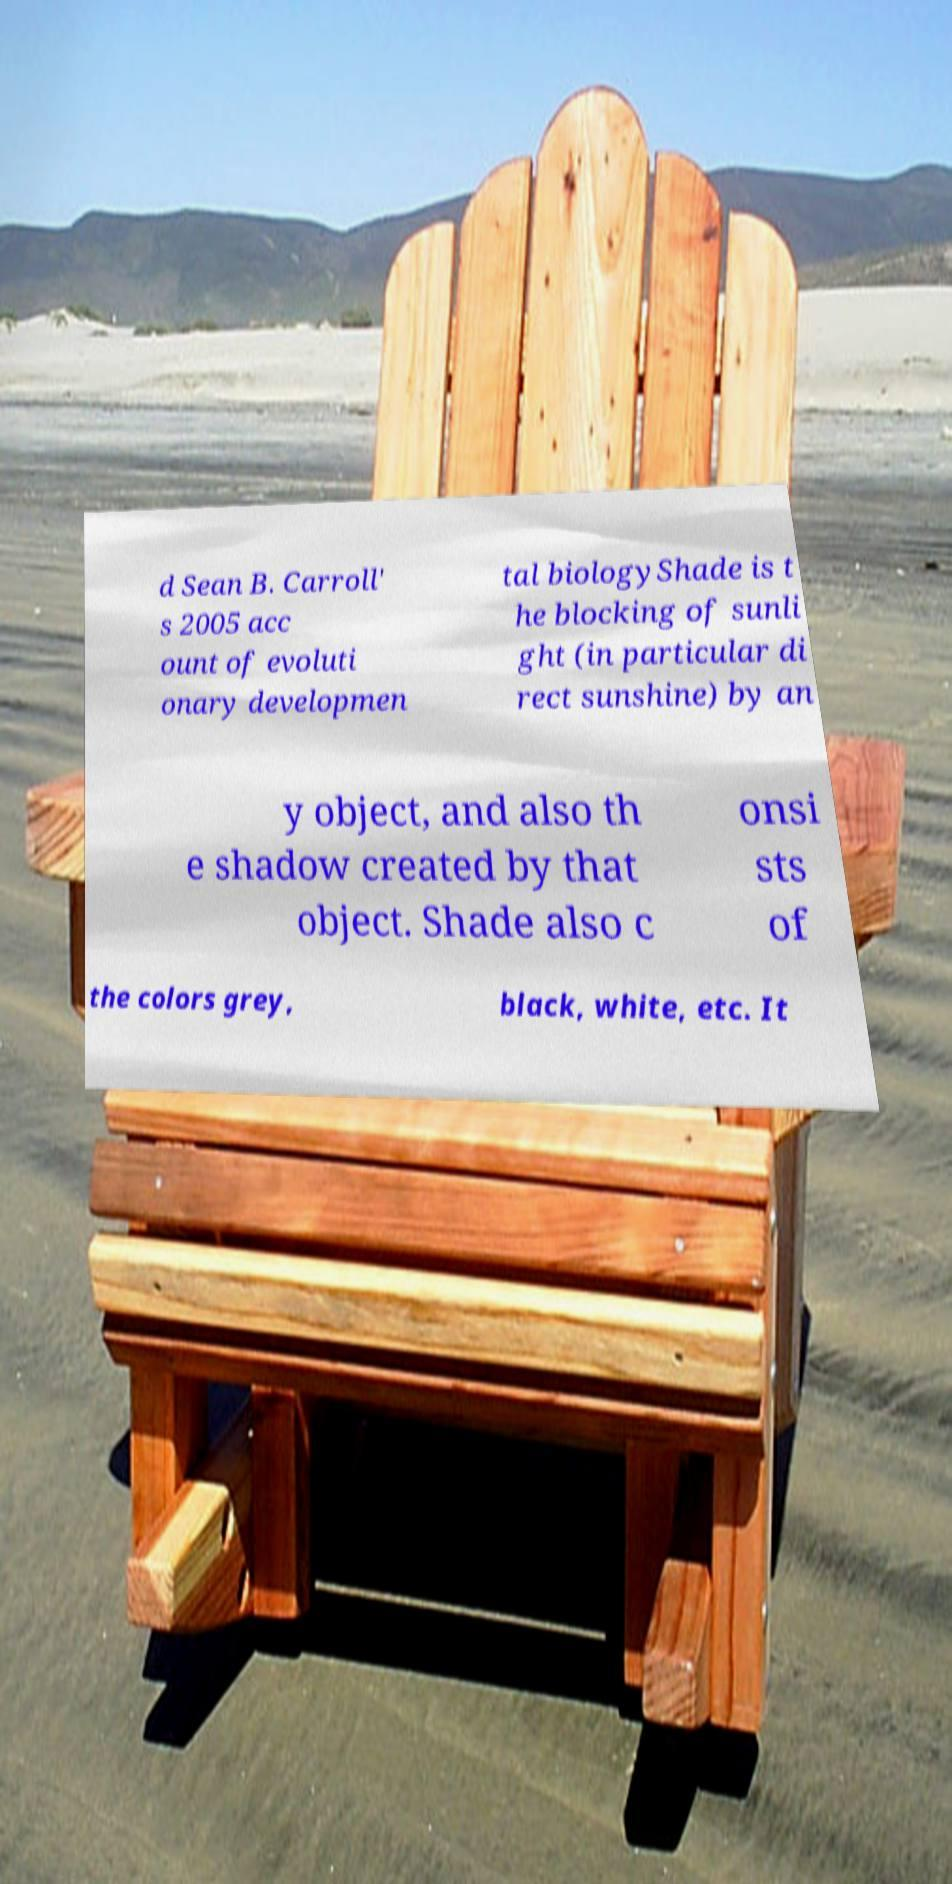Could you assist in decoding the text presented in this image and type it out clearly? d Sean B. Carroll' s 2005 acc ount of evoluti onary developmen tal biologyShade is t he blocking of sunli ght (in particular di rect sunshine) by an y object, and also th e shadow created by that object. Shade also c onsi sts of the colors grey, black, white, etc. It 